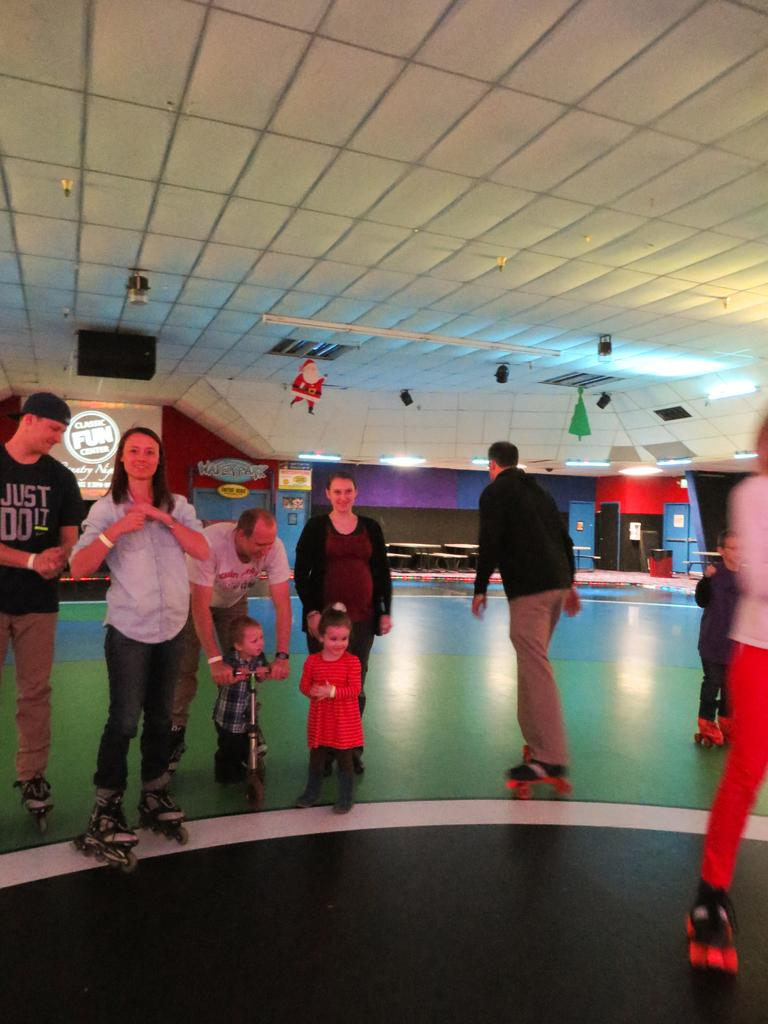What is happening in the center of the image? There are people standing in the center of the image. What can be seen in the background of the image? There is a wall in the background of the image. What is located at the top of the image? There is a ceiling with lights at the top of the image. What type of thrill can be seen on the people's faces in the image? There is no indication of any specific emotion or thrill on the people's faces in the image. How many thumbs can be seen on the people in the image? The number of thumbs cannot be determined from the image, as it only shows the people from the waist up. 